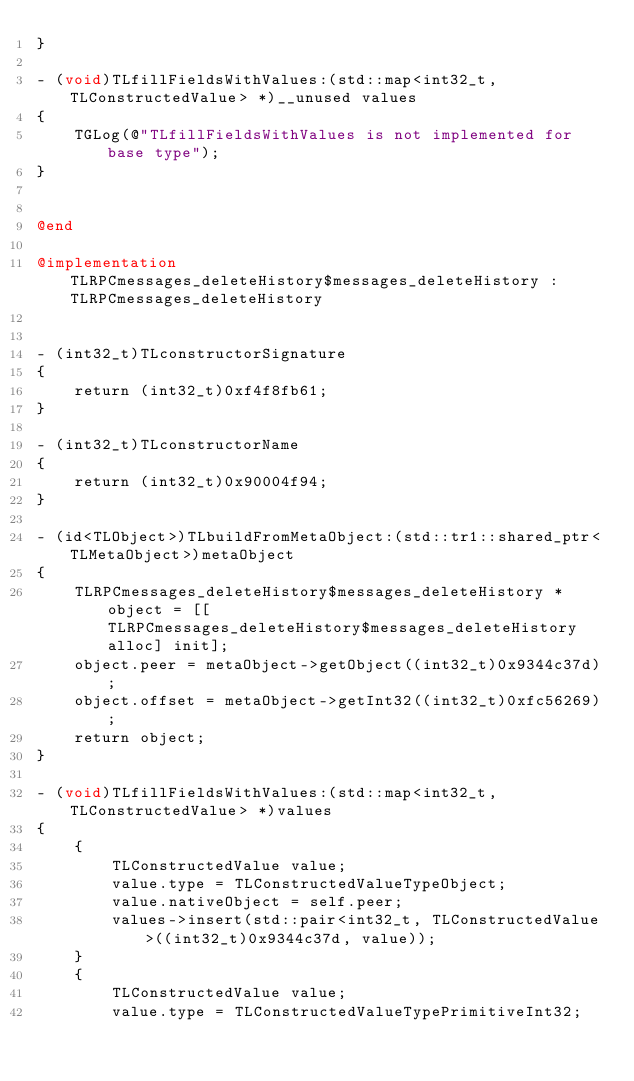<code> <loc_0><loc_0><loc_500><loc_500><_ObjectiveC_>}

- (void)TLfillFieldsWithValues:(std::map<int32_t, TLConstructedValue> *)__unused values
{
    TGLog(@"TLfillFieldsWithValues is not implemented for base type");
}


@end

@implementation TLRPCmessages_deleteHistory$messages_deleteHistory : TLRPCmessages_deleteHistory


- (int32_t)TLconstructorSignature
{
    return (int32_t)0xf4f8fb61;
}

- (int32_t)TLconstructorName
{
    return (int32_t)0x90004f94;
}

- (id<TLObject>)TLbuildFromMetaObject:(std::tr1::shared_ptr<TLMetaObject>)metaObject
{
    TLRPCmessages_deleteHistory$messages_deleteHistory *object = [[TLRPCmessages_deleteHistory$messages_deleteHistory alloc] init];
    object.peer = metaObject->getObject((int32_t)0x9344c37d);
    object.offset = metaObject->getInt32((int32_t)0xfc56269);
    return object;
}

- (void)TLfillFieldsWithValues:(std::map<int32_t, TLConstructedValue> *)values
{
    {
        TLConstructedValue value;
        value.type = TLConstructedValueTypeObject;
        value.nativeObject = self.peer;
        values->insert(std::pair<int32_t, TLConstructedValue>((int32_t)0x9344c37d, value));
    }
    {
        TLConstructedValue value;
        value.type = TLConstructedValueTypePrimitiveInt32;</code> 